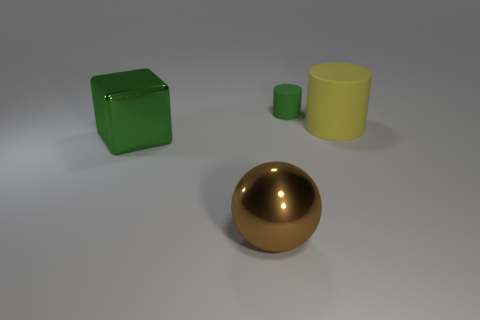Add 4 small green objects. How many objects exist? 8 Subtract all spheres. How many objects are left? 3 Subtract all small red metallic cylinders. Subtract all large green things. How many objects are left? 3 Add 4 large yellow cylinders. How many large yellow cylinders are left? 5 Add 2 large metallic blocks. How many large metallic blocks exist? 3 Subtract 0 green spheres. How many objects are left? 4 Subtract all purple cylinders. Subtract all gray spheres. How many cylinders are left? 2 